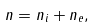<formula> <loc_0><loc_0><loc_500><loc_500>n = n _ { i } + n _ { e } ,</formula> 